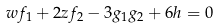Convert formula to latex. <formula><loc_0><loc_0><loc_500><loc_500>w f _ { 1 } + 2 z f _ { 2 } - 3 g _ { 1 } g _ { 2 } + 6 h = 0</formula> 